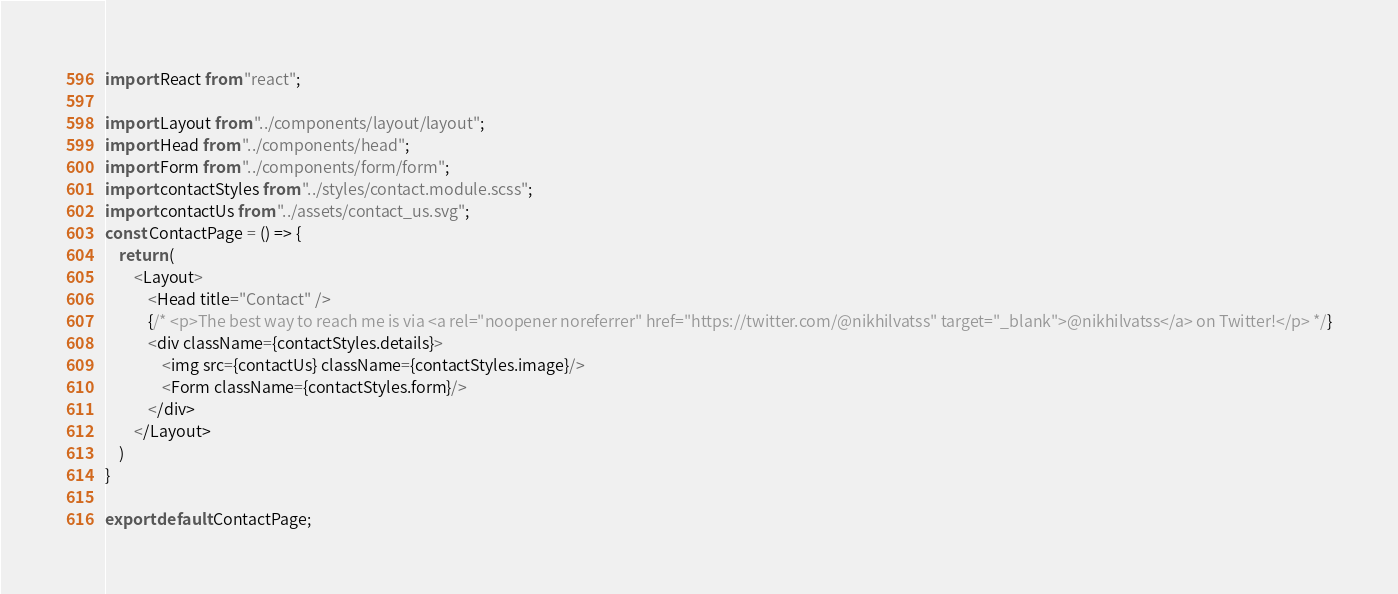<code> <loc_0><loc_0><loc_500><loc_500><_JavaScript_>import React from "react";

import Layout from "../components/layout/layout";
import Head from "../components/head";
import Form from "../components/form/form";
import contactStyles from "../styles/contact.module.scss";
import contactUs from "../assets/contact_us.svg";
const ContactPage = () => {
    return (
        <Layout>
            <Head title="Contact" />
            {/* <p>The best way to reach me is via <a rel="noopener noreferrer" href="https://twitter.com/@nikhilvatss" target="_blank">@nikhilvatss</a> on Twitter!</p> */}
            <div className={contactStyles.details}>
                <img src={contactUs} className={contactStyles.image}/>   
                <Form className={contactStyles.form}/>
            </div>
        </Layout>
    )
}

export default ContactPage;</code> 